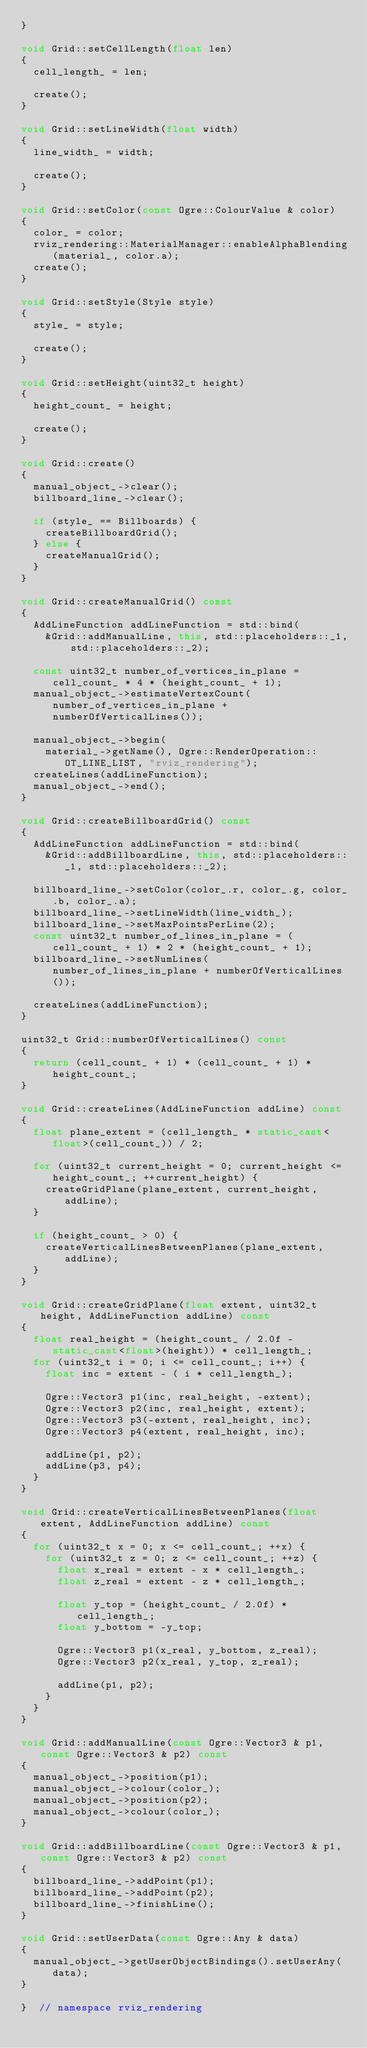<code> <loc_0><loc_0><loc_500><loc_500><_C++_>}

void Grid::setCellLength(float len)
{
  cell_length_ = len;

  create();
}

void Grid::setLineWidth(float width)
{
  line_width_ = width;

  create();
}

void Grid::setColor(const Ogre::ColourValue & color)
{
  color_ = color;
  rviz_rendering::MaterialManager::enableAlphaBlending(material_, color.a);
  create();
}

void Grid::setStyle(Style style)
{
  style_ = style;

  create();
}

void Grid::setHeight(uint32_t height)
{
  height_count_ = height;

  create();
}

void Grid::create()
{
  manual_object_->clear();
  billboard_line_->clear();

  if (style_ == Billboards) {
    createBillboardGrid();
  } else {
    createManualGrid();
  }
}

void Grid::createManualGrid() const
{
  AddLineFunction addLineFunction = std::bind(
    &Grid::addManualLine, this, std::placeholders::_1, std::placeholders::_2);

  const uint32_t number_of_vertices_in_plane = cell_count_ * 4 * (height_count_ + 1);
  manual_object_->estimateVertexCount(number_of_vertices_in_plane + numberOfVerticalLines());

  manual_object_->begin(
    material_->getName(), Ogre::RenderOperation::OT_LINE_LIST, "rviz_rendering");
  createLines(addLineFunction);
  manual_object_->end();
}

void Grid::createBillboardGrid() const
{
  AddLineFunction addLineFunction = std::bind(
    &Grid::addBillboardLine, this, std::placeholders::_1, std::placeholders::_2);

  billboard_line_->setColor(color_.r, color_.g, color_.b, color_.a);
  billboard_line_->setLineWidth(line_width_);
  billboard_line_->setMaxPointsPerLine(2);
  const uint32_t number_of_lines_in_plane = (cell_count_ + 1) * 2 * (height_count_ + 1);
  billboard_line_->setNumLines(number_of_lines_in_plane + numberOfVerticalLines());

  createLines(addLineFunction);
}

uint32_t Grid::numberOfVerticalLines() const
{
  return (cell_count_ + 1) * (cell_count_ + 1) * height_count_;
}

void Grid::createLines(AddLineFunction addLine) const
{
  float plane_extent = (cell_length_ * static_cast<float>(cell_count_)) / 2;

  for (uint32_t current_height = 0; current_height <= height_count_; ++current_height) {
    createGridPlane(plane_extent, current_height, addLine);
  }

  if (height_count_ > 0) {
    createVerticalLinesBetweenPlanes(plane_extent, addLine);
  }
}

void Grid::createGridPlane(float extent, uint32_t height, AddLineFunction addLine) const
{
  float real_height = (height_count_ / 2.0f - static_cast<float>(height)) * cell_length_;
  for (uint32_t i = 0; i <= cell_count_; i++) {
    float inc = extent - ( i * cell_length_);

    Ogre::Vector3 p1(inc, real_height, -extent);
    Ogre::Vector3 p2(inc, real_height, extent);
    Ogre::Vector3 p3(-extent, real_height, inc);
    Ogre::Vector3 p4(extent, real_height, inc);

    addLine(p1, p2);
    addLine(p3, p4);
  }
}

void Grid::createVerticalLinesBetweenPlanes(float extent, AddLineFunction addLine) const
{
  for (uint32_t x = 0; x <= cell_count_; ++x) {
    for (uint32_t z = 0; z <= cell_count_; ++z) {
      float x_real = extent - x * cell_length_;
      float z_real = extent - z * cell_length_;

      float y_top = (height_count_ / 2.0f) * cell_length_;
      float y_bottom = -y_top;

      Ogre::Vector3 p1(x_real, y_bottom, z_real);
      Ogre::Vector3 p2(x_real, y_top, z_real);

      addLine(p1, p2);
    }
  }
}

void Grid::addManualLine(const Ogre::Vector3 & p1, const Ogre::Vector3 & p2) const
{
  manual_object_->position(p1);
  manual_object_->colour(color_);
  manual_object_->position(p2);
  manual_object_->colour(color_);
}

void Grid::addBillboardLine(const Ogre::Vector3 & p1, const Ogre::Vector3 & p2) const
{
  billboard_line_->addPoint(p1);
  billboard_line_->addPoint(p2);
  billboard_line_->finishLine();
}

void Grid::setUserData(const Ogre::Any & data)
{
  manual_object_->getUserObjectBindings().setUserAny(data);
}

}  // namespace rviz_rendering
</code> 